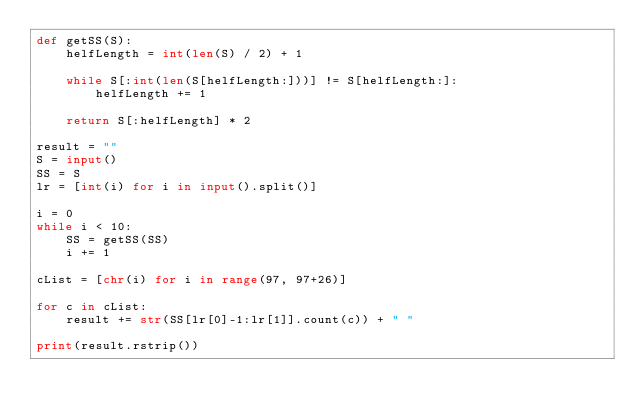<code> <loc_0><loc_0><loc_500><loc_500><_Python_>def getSS(S):
    helfLength = int(len(S) / 2) + 1
    
    while S[:int(len(S[helfLength:]))] != S[helfLength:]:
        helfLength += 1
        
    return S[:helfLength] * 2

result = ""
S = input()
SS = S
lr = [int(i) for i in input().split()]

i = 0
while i < 10:
    SS = getSS(SS)
    i += 1

cList = [chr(i) for i in range(97, 97+26)]

for c in cList:
    result += str(SS[lr[0]-1:lr[1]].count(c)) + " "

print(result.rstrip())</code> 